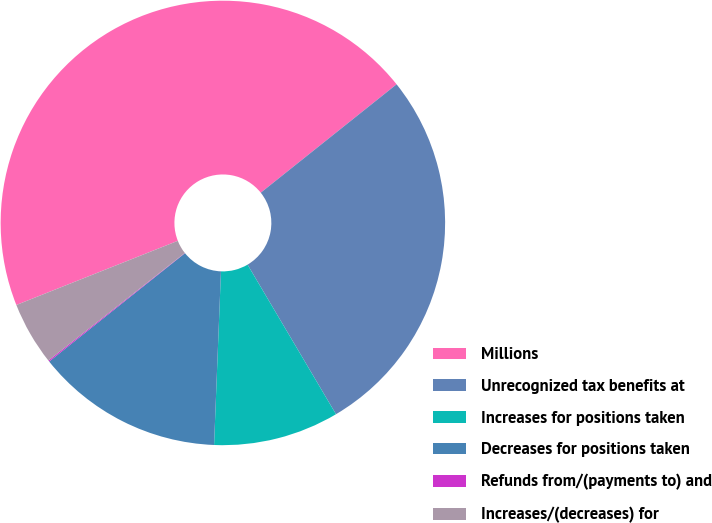Convert chart. <chart><loc_0><loc_0><loc_500><loc_500><pie_chart><fcel>Millions<fcel>Unrecognized tax benefits at<fcel>Increases for positions taken<fcel>Decreases for positions taken<fcel>Refunds from/(payments to) and<fcel>Increases/(decreases) for<nl><fcel>45.3%<fcel>27.22%<fcel>9.13%<fcel>13.65%<fcel>0.09%<fcel>4.61%<nl></chart> 